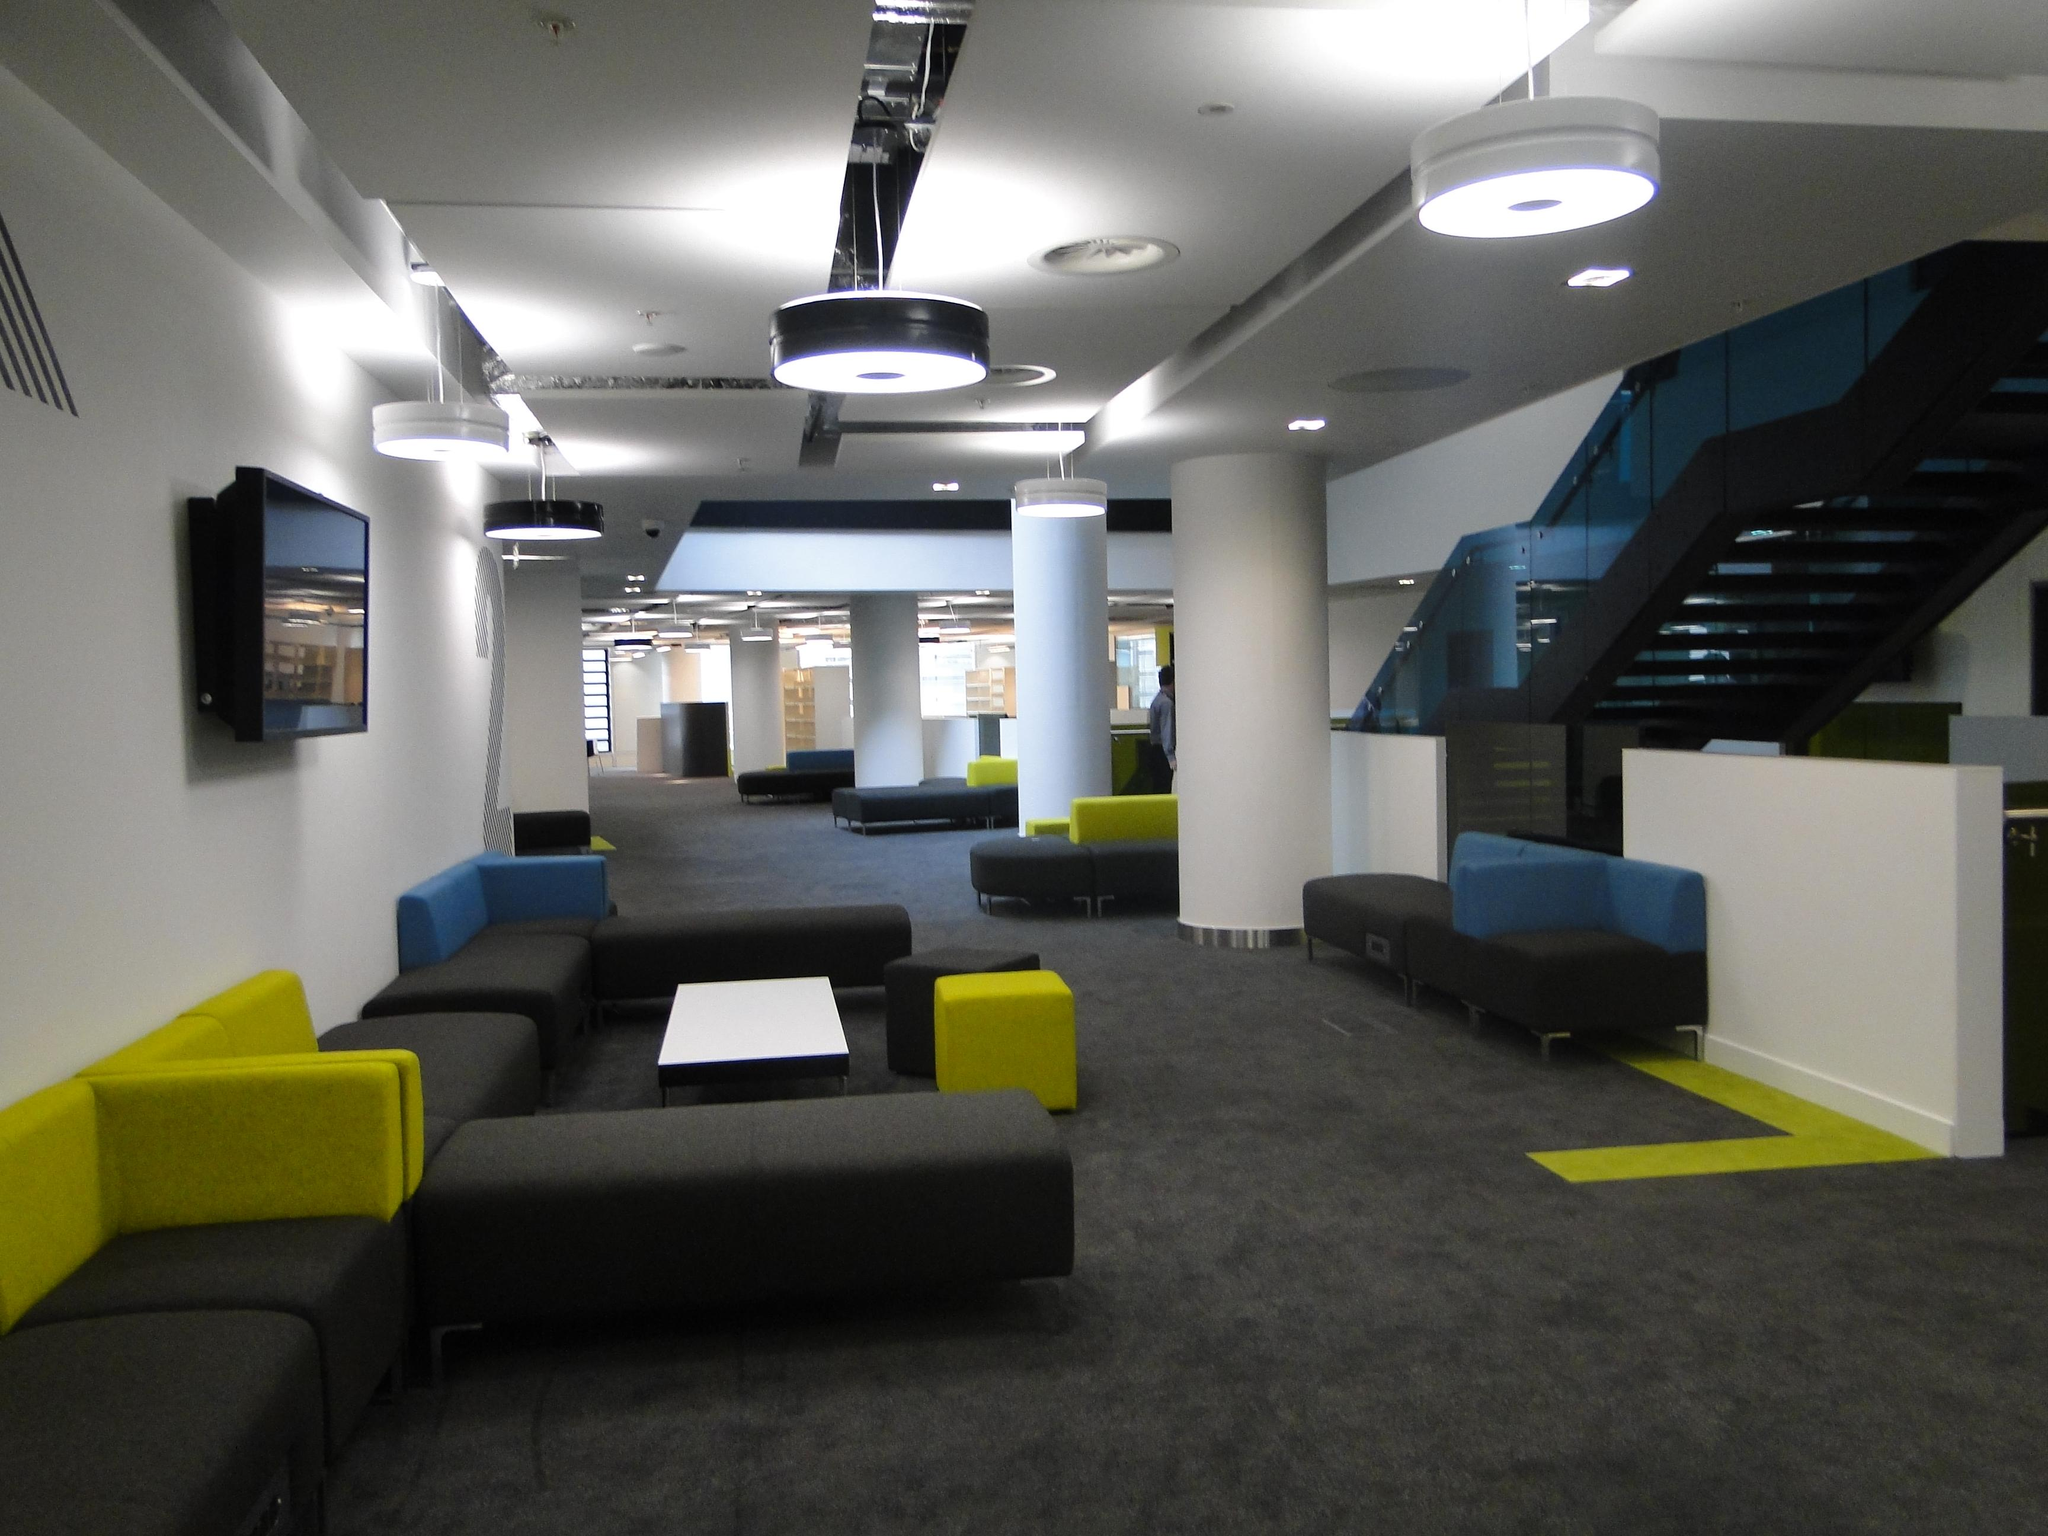Where is the setting of the image? The image is inside a room. What architectural features can be seen in the room? There are many pillars in the room. What type of furniture is present in the room? There are sofas, at least one table, and chairs in the room. What lighting is available in the room? There are lights in the room. What is mounted on the wall in the room? There is a TV on the wall. What advertisement is being displayed on the TV in the image? There is no advertisement being displayed on the TV in the image; it is not mentioned in the provided facts. 